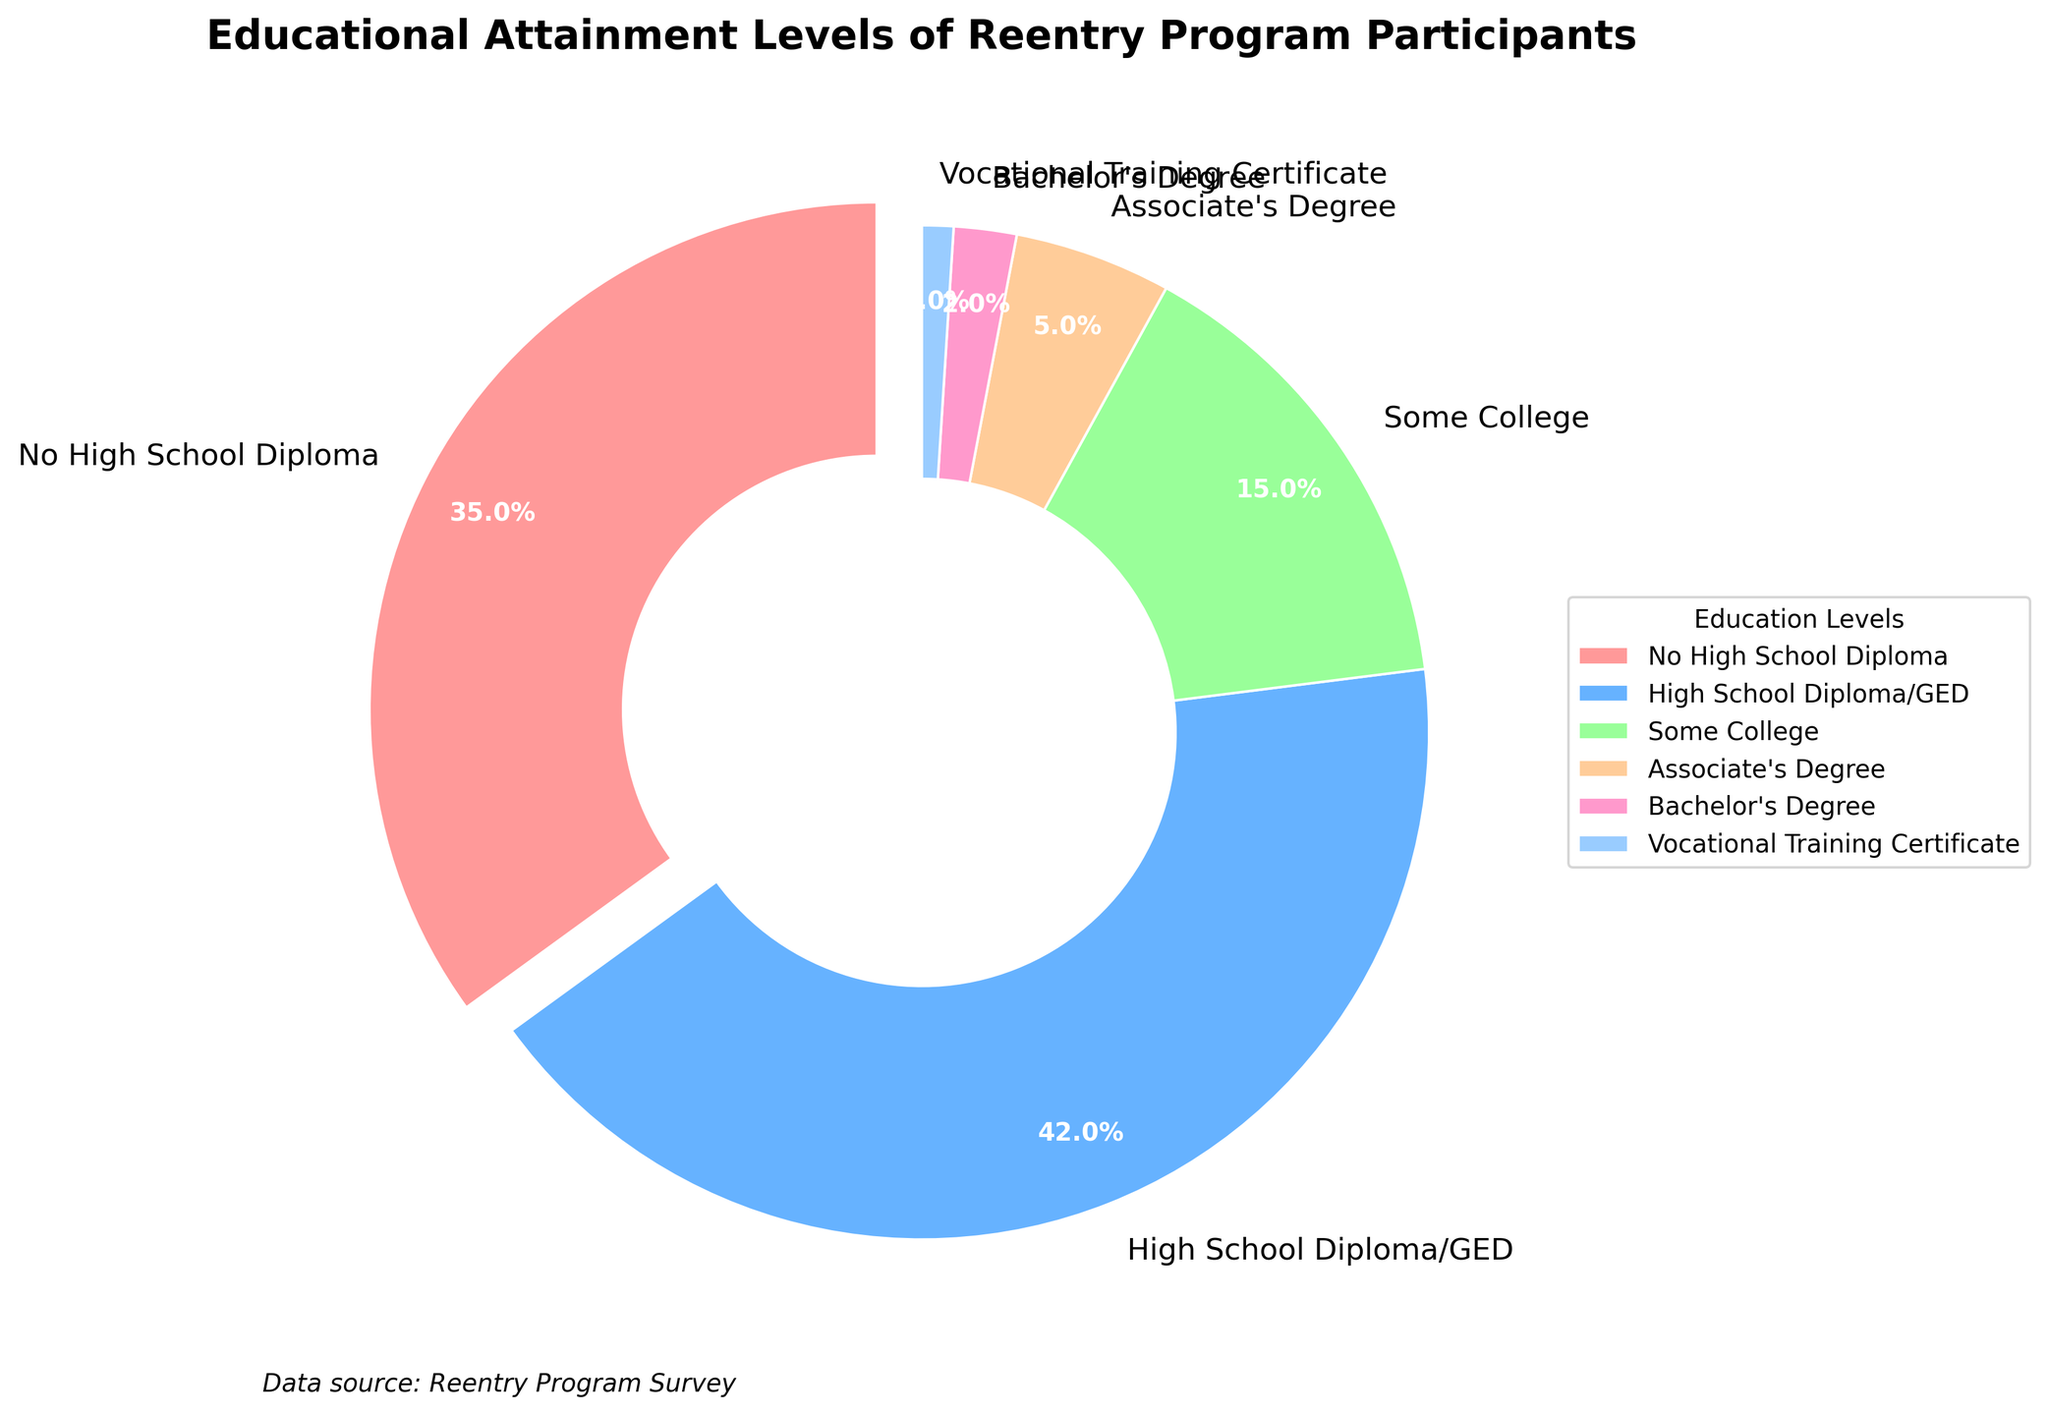What percentage of participants have at least a high school diploma/GED? To find this, add the percentages for "High School Diploma/GED", "Some College", "Associate's Degree", "Bachelor's Degree", and "Vocational Training Certificate". This gives us 42 + 15 + 5 + 2 + 1 = 65%.
Answer: 65% Which educational level has the highest percentage of participants? By looking at the pie chart, the "High School Diploma/GED" section has the largest size, indicating it has the highest percentage of participants at 42%.
Answer: High School Diploma/GED Which educational levels cumulatively represent exactly 20% of the participants? To find this combination, consider the smaller sections: "Vocational Training Certificate" (1%) + "Bachelor's Degree" (2%) + "Associate's Degree" (5%) + "Some College" (15%) = 1+2+5+15 = 23%. Instead, "Associate's Degree" (5%) + "Some College" (15%) = 20%.
Answer: Associate's Degree, Some College Within the participants, how do the percentages of those with no high school diploma compare to those with some college education? The percentage with "No High School Diploma" is 35%, whereas the percentage with "Some College" is 15%. Thus, 35% is greater than 15%.
Answer: No High School Diploma > Some College What fraction of the pie chart is made up of participants with an Associate's Degree or a Bachelor's Degree? The percentage for "Associate's Degree" is 5% and for "Bachelor's Degree" is 2%. The total is 5 + 2 = 7%. To convert to a fraction, 7% of 100% is 7/100, which simplifies to 7/100.
Answer: 7/100 What is the combined percentage of participants with the least common educational attainment levels? The least common educational levels are "Bachelor's Degree" (2%) and "Vocational Training Certificate" (1%). Their combined percentage is 2 + 1 = 3%.
Answer: 3% How does the size of the slice representing "Some College" compare visually to the slice representing "No High School Diploma"? By observing the pie chart, the "No High School Diploma" slice is significantly larger than the "Some College" slice.
Answer: No High School Diploma > Some College What is the total percentage of participants that have an educational level ranging from some college to a bachelor's degree? Add the percentages for "Some College", "Associate's Degree", and "Bachelor's Degree". This gives us 15 + 5 + 2 = 22%.
Answer: 22% Identify the color associated with the section representing participants with a high school diploma or GED. By looking at the pie chart, the section for "High School Diploma/GED" is in blue.
Answer: Blue 